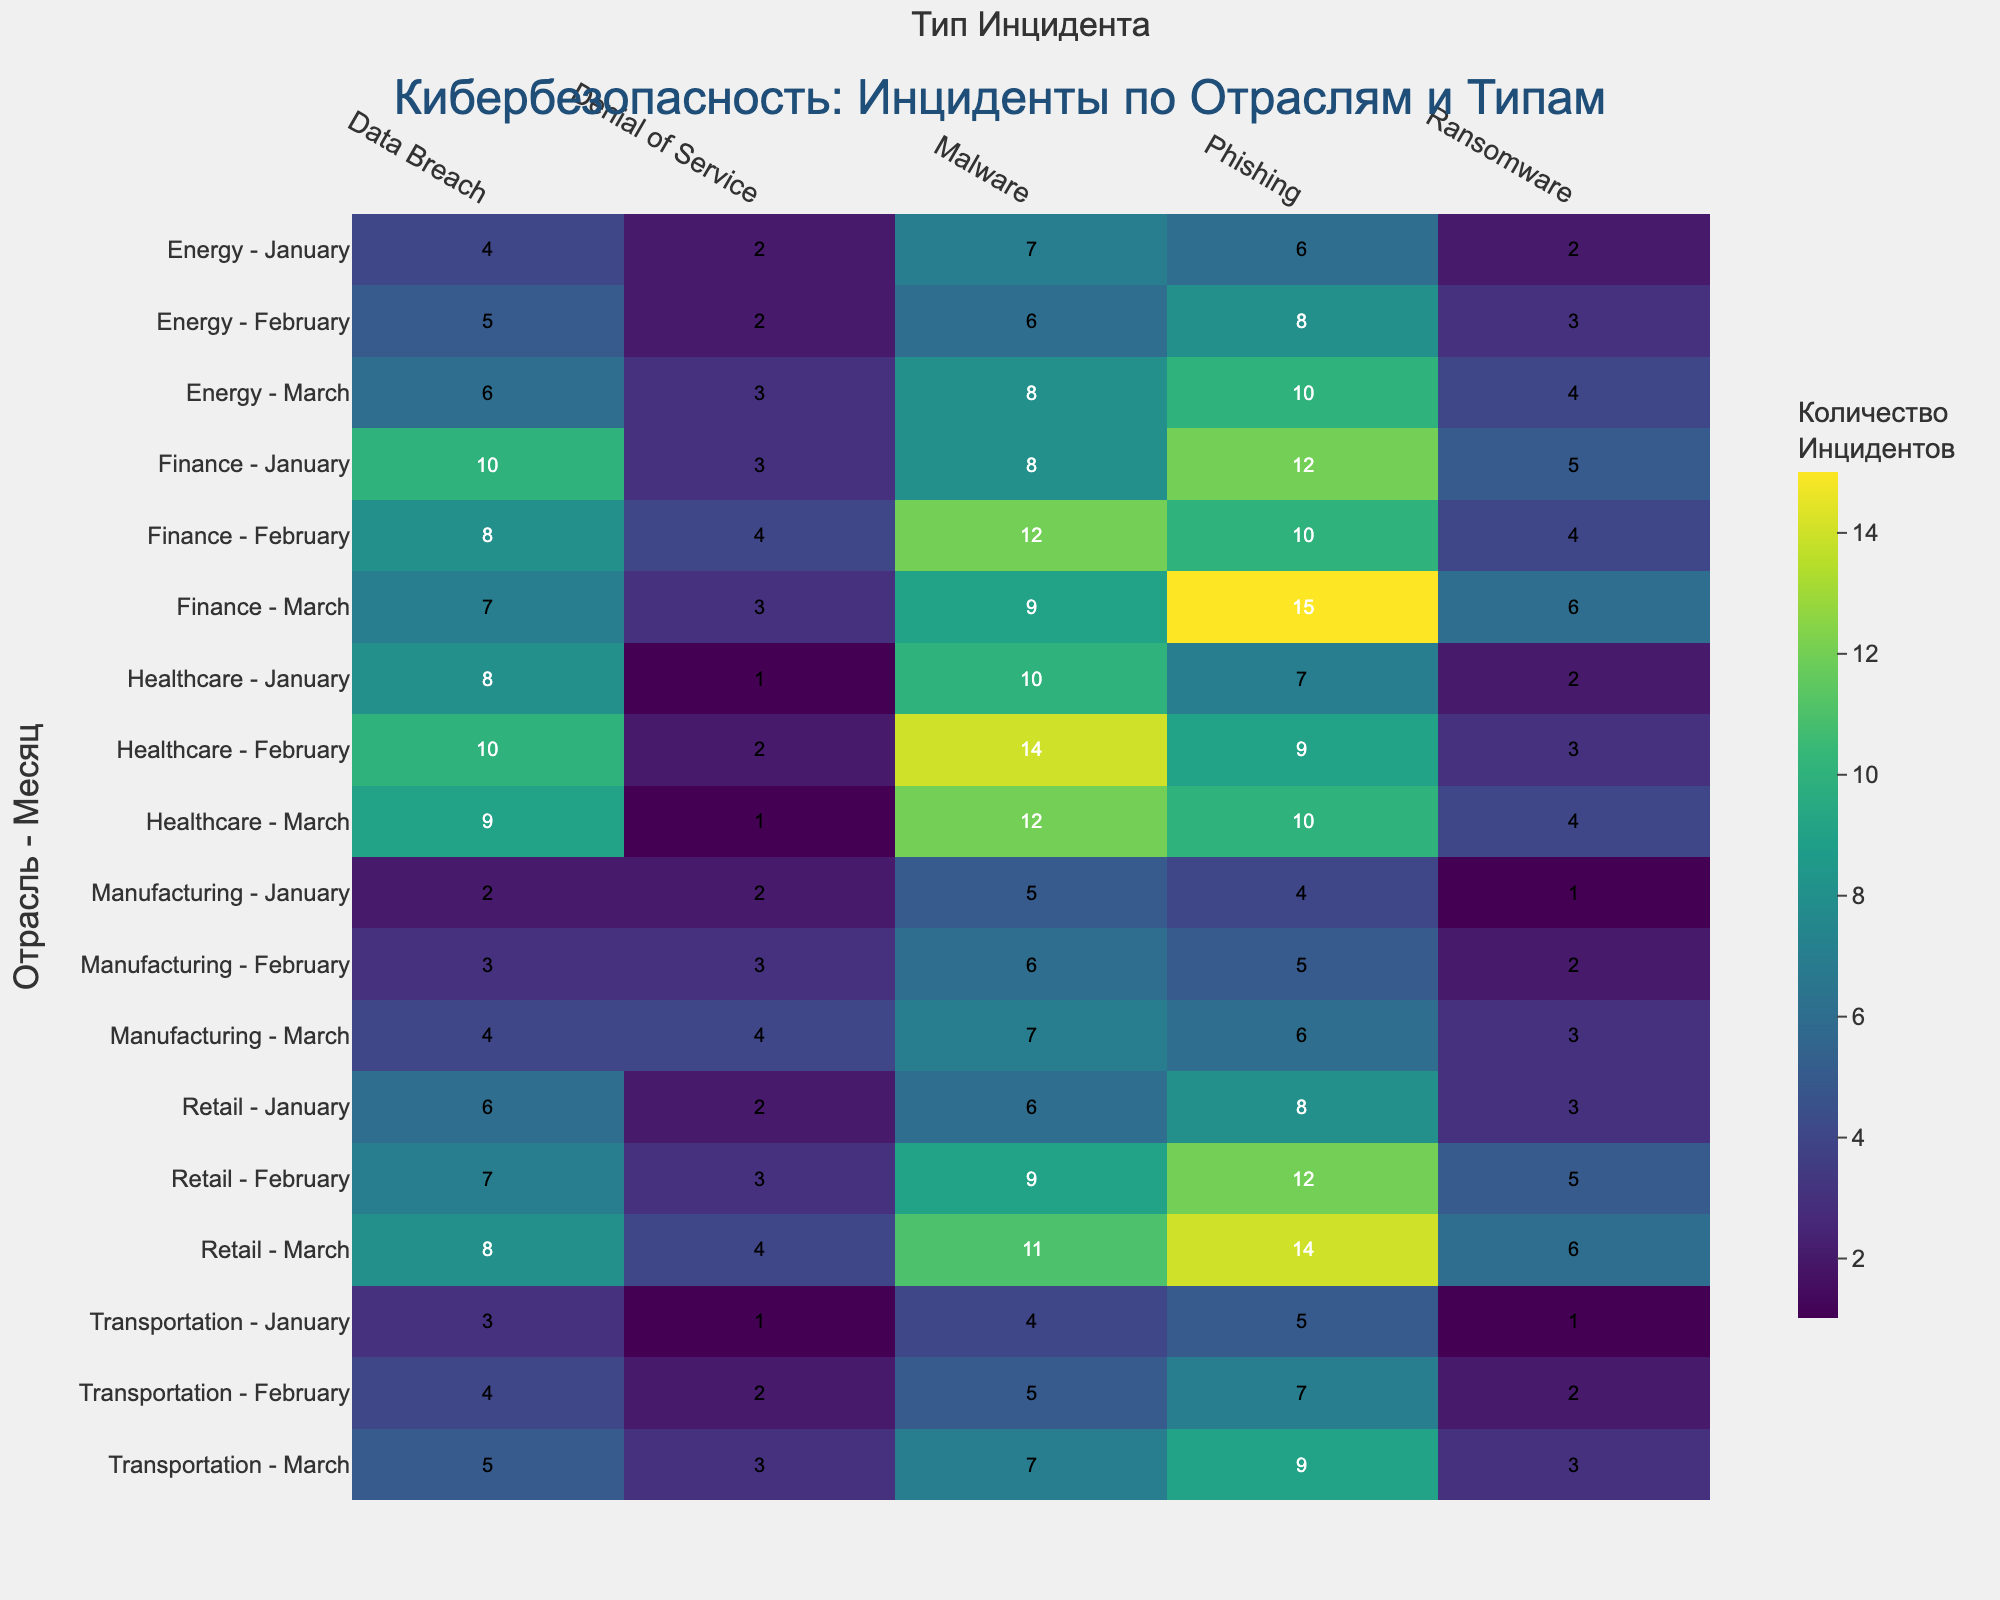How many incidents of Phishing were reported in the Finance industry in February? Locate the Finance row corresponding to February and find the value under the Phishing column.
Answer: 10 Which industry had the highest number of Malware incidents in March? Identify the row for each industry in March and compare the Malware values. The highest value will indicate the industry.
Answer: Retail What is the total number of Ransomware incidents reported across all industries in January? Sum the Ransomware values for January across all industries: 5 (Finance) + 2 (Healthcare) + 3 (Retail) + 1 (Transportation) + 2 (Energy) + 1 (Manufacturing) = 14.
Answer: 14 Which industry had fewer Data Breach incidents in January, Energy or Healthcare? Compare the Data Breach values for January between Energy (4) and Healthcare (8).
Answer: Energy What is the average number of Denial of Service incidents reported in the Manufacturing industry over the three months? Sum the Denial of Service incidents for Manufacturing: 2 (January) + 3 (February) + 4 (March) = 9. Average: 9 / 3 = 3.
Answer: 3 What is the highest number of incidents reported for any type in any industry and month combination? Examine the values across all industries and months to find the largest single value in any type column.
Answer: 15 (Phishing in Finance for March) Which month had the highest cumulative number of Phishing incidents across all industries? Sum the Phishing incidents for each month across all industries and compare: January (12+7+8+5+6+4), February (10+9+12+7+8+5), March (15+10+14+9+10+6). The month with the highest sum is identified.
Answer: March 